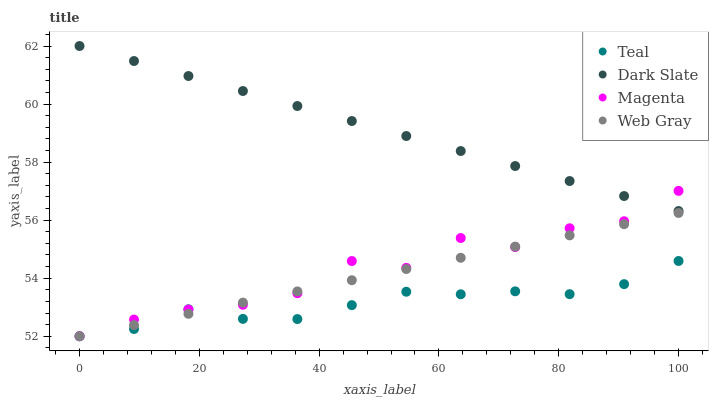Does Teal have the minimum area under the curve?
Answer yes or no. Yes. Does Dark Slate have the maximum area under the curve?
Answer yes or no. Yes. Does Magenta have the minimum area under the curve?
Answer yes or no. No. Does Magenta have the maximum area under the curve?
Answer yes or no. No. Is Dark Slate the smoothest?
Answer yes or no. Yes. Is Magenta the roughest?
Answer yes or no. Yes. Is Web Gray the smoothest?
Answer yes or no. No. Is Web Gray the roughest?
Answer yes or no. No. Does Magenta have the lowest value?
Answer yes or no. Yes. Does Dark Slate have the highest value?
Answer yes or no. Yes. Does Magenta have the highest value?
Answer yes or no. No. Is Web Gray less than Dark Slate?
Answer yes or no. Yes. Is Dark Slate greater than Web Gray?
Answer yes or no. Yes. Does Magenta intersect Teal?
Answer yes or no. Yes. Is Magenta less than Teal?
Answer yes or no. No. Is Magenta greater than Teal?
Answer yes or no. No. Does Web Gray intersect Dark Slate?
Answer yes or no. No. 